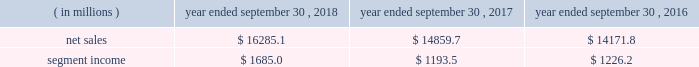Holders of grupo gondi manage the joint venture and we provide technical and commercial resources .
We believe the joint venture is helping us to grow our presence in the attractive mexican market .
We have included the financial results of the joint venture in our corrugated packaging segment since the date of formation .
We are accounting for the investment on the equity method .
On january 19 , 2016 , we completed the packaging acquisition .
The entities acquired provide value-added folding carton and litho-laminated display packaging solutions .
We believe the transaction has provided us with attractive and complementary customers , markets and facilities .
We have included the financial results of the acquired entities in our consumer packaging segment since the date of the acquisition .
On october 1 , 2015 , we completed the sp fiber acquisition .
The transaction included the acquisition of mills located in dublin , ga and newberg , or , which produce lightweight recycled containerboard and kraft and bag paper .
The newberg mill also produced newsprint .
As part of the transaction , we also acquired sp fiber's 48% ( 48 % ) interest in green power solutions of georgia , llc ( fffdgps fffd ) , which we consolidate .
Gps is a joint venture providing steam to the dublin mill and electricity to georgia power .
Subsequent to the transaction , we announced the permanent closure of the newberg mill due to the decline in market conditions of the newsprint business and our need to balance supply and demand in our containerboard system .
We have included the financial results of the acquired entities in our corrugated packaging segment since the date of the acquisition .
See fffdnote 2 .
Mergers , acquisitions and investment fffdtt of the notes to consolidated financial statements for additional information .
See also item 1a .
Fffdrisk factors fffd fffdwe may be unsuccessful in making and integrating mergers , acquisitions and investments and completing divestitures fffd .
Business .
In fiscal 2018 , we continued to pursue our strategy of offering differentiated paper and packaging solutions that help our customers win .
We successfully executed this strategy in fiscal 2018 in a rapidly changing cost and price environment .
Net sales of $ 16285.1 million for fiscal 2018 increased $ 1425.4 million , or 9.6% ( 9.6 % ) , compared to fiscal 2017 .
The increase was primarily a result of an increase in corrugated packaging segment sales , driven by higher selling price/mix and the contributions from acquisitions , and increased consumer packaging segment sales , primarily due to the contribution from acquisitions ( primarily the mps acquisition ) .
These increases were partially offset by the absence of net sales from hh&b in fiscal 2018 due to the sale of hh&b in april 2017 and lower land and development segment sales compared to the prior year period due to the timing of real estate sales as we monetize the portfolio and lower merchandising display sales in the consumer packaging segment .
Segment income increased $ 491.5 million in fiscal 2018 compared to fiscal 2017 , primarily due to increased corrugated packaging segment income .
With respect to segment income , we experienced higher levels of cost inflation during fiscal 2018 as compared to fiscal 2017 , which was partially offset by recycled fiber deflation .
The primary inflationary items were freight costs , chemical costs , virgin fiber costs and wage and other costs .
Productivity improvements in fiscal 2018 more than offset the net impact of cost inflation .
While it is difficult to predict specific inflationary items , we expect higher cost inflation to continue through fiscal 2019 .
Our corrugated packaging segment increased its net sales by $ 695.1 million in fiscal 2018 to $ 9103.4 million from $ 8408.3 million in fiscal 2017 .
The increase in net sales was primarily due to higher corrugated selling price/mix and higher corrugated volumes ( including acquisitions ) , which were partially offset by lower net sales from recycling operations due to lower recycled fiber costs , lower sales related to the deconsolidation of a foreign joint venture in fiscal 2017 and the impact of foreign currency .
North american box shipments increased 4.1% ( 4.1 % ) on a per day basis in fiscal 2018 compared to fiscal 2017 .
Segment income attributable to the corrugated packaging segment in fiscal 2018 increased $ 454.0 million to $ 1207.9 million compared to $ 753.9 million in fiscal 2017 .
The increase was primarily due to higher selling price/mix , lower recycled fiber costs and productivity improvements which were partially offset by higher levels of cost inflation and other items , including increased depreciation and amortization .
Our consumer packaging segment increased its net sales by $ 838.9 million in fiscal 2018 to $ 7291.4 million from $ 6452.5 million in fiscal 2017 .
The increase in net sales was primarily due to an increase in net sales from acquisitions ( primarily the mps acquisition ) and higher selling price/mix partially offset by the absence of net sales from hh&b in fiscal 2018 due to the hh&b sale in april 2017 and lower volumes .
Segment income attributable to .
What was the percentage growth in the consumer packaging segment net sales in 2018 from 2017 by $ million in fiscal 2018 to $ 7291.4 million from $ million in fiscal 2017 .? 
Computations: (838.9 / 6452.5)
Answer: 0.13001. 